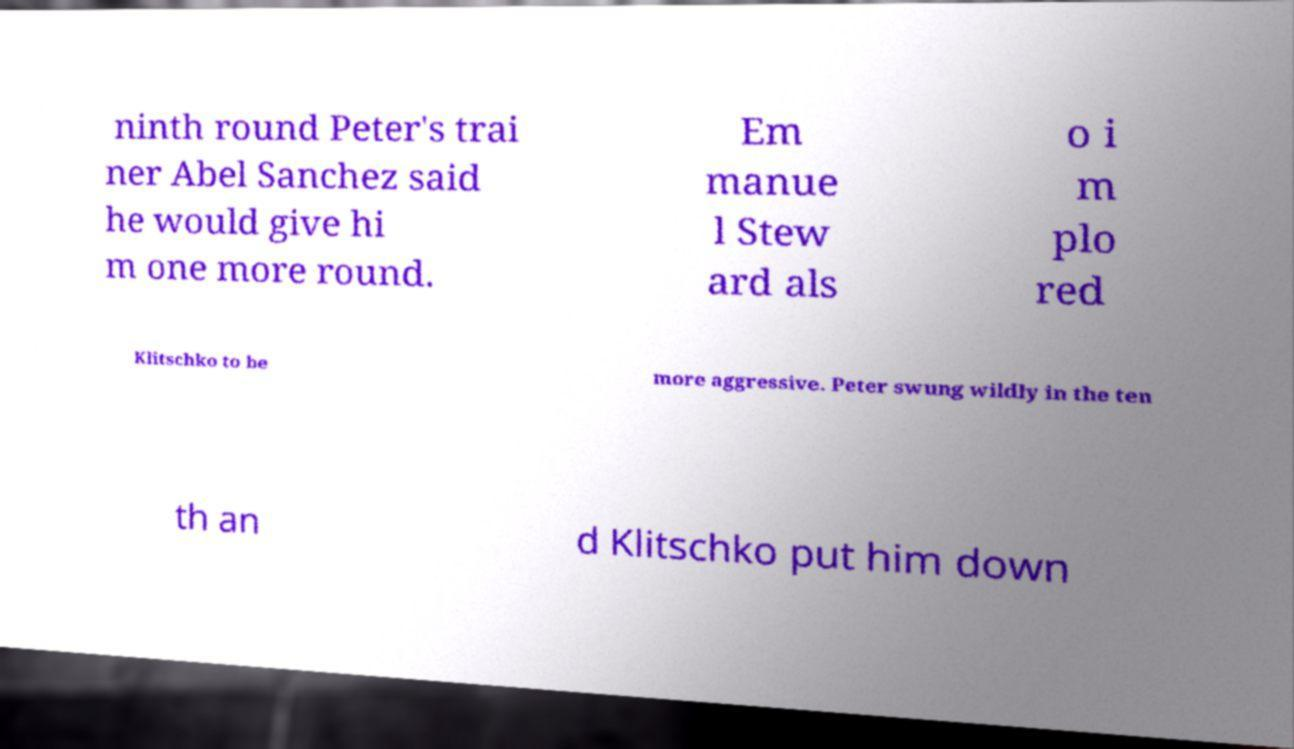Can you accurately transcribe the text from the provided image for me? ninth round Peter's trai ner Abel Sanchez said he would give hi m one more round. Em manue l Stew ard als o i m plo red Klitschko to be more aggressive. Peter swung wildly in the ten th an d Klitschko put him down 